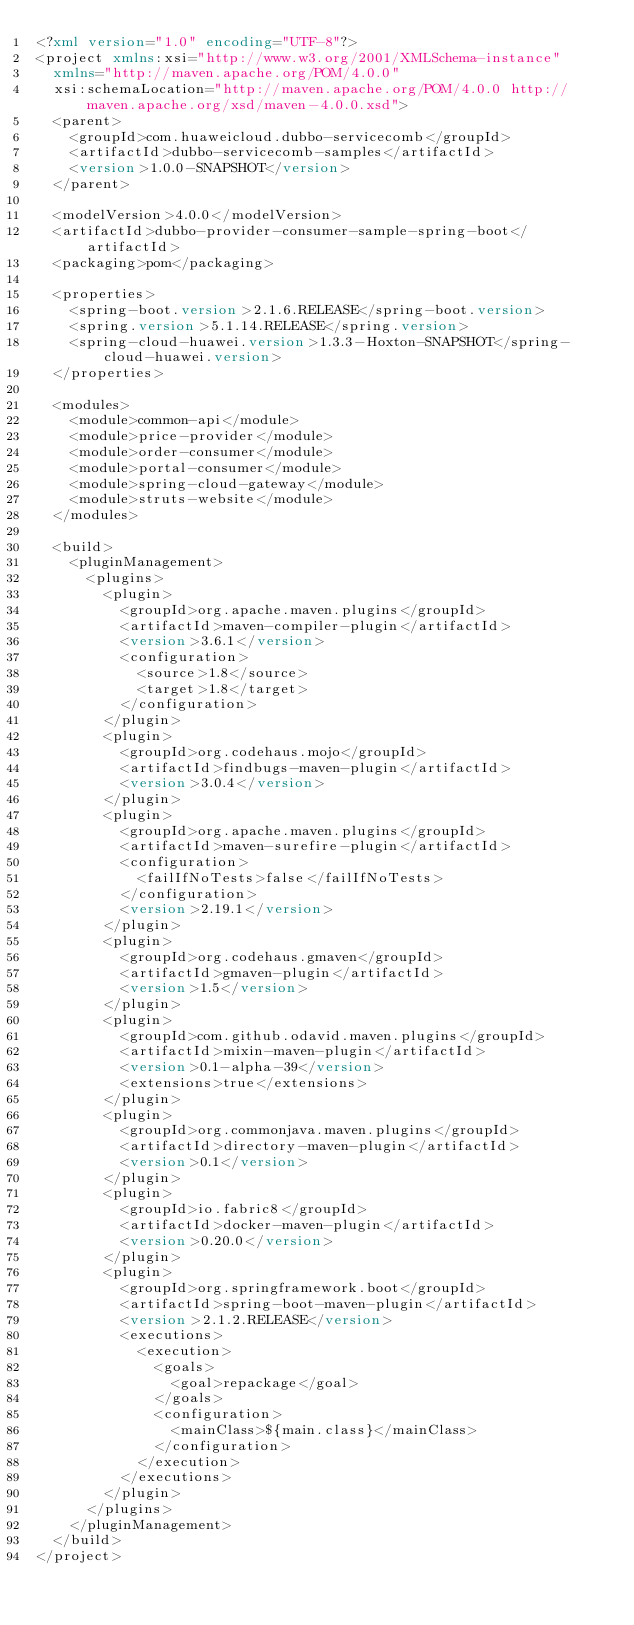<code> <loc_0><loc_0><loc_500><loc_500><_XML_><?xml version="1.0" encoding="UTF-8"?>
<project xmlns:xsi="http://www.w3.org/2001/XMLSchema-instance"
  xmlns="http://maven.apache.org/POM/4.0.0"
  xsi:schemaLocation="http://maven.apache.org/POM/4.0.0 http://maven.apache.org/xsd/maven-4.0.0.xsd">
  <parent>
    <groupId>com.huaweicloud.dubbo-servicecomb</groupId>
    <artifactId>dubbo-servicecomb-samples</artifactId>
    <version>1.0.0-SNAPSHOT</version>
  </parent>

  <modelVersion>4.0.0</modelVersion>
  <artifactId>dubbo-provider-consumer-sample-spring-boot</artifactId>
  <packaging>pom</packaging>

  <properties>
    <spring-boot.version>2.1.6.RELEASE</spring-boot.version>
    <spring.version>5.1.14.RELEASE</spring.version>
    <spring-cloud-huawei.version>1.3.3-Hoxton-SNAPSHOT</spring-cloud-huawei.version>
  </properties>

  <modules>
    <module>common-api</module>
    <module>price-provider</module>
    <module>order-consumer</module>
    <module>portal-consumer</module>
    <module>spring-cloud-gateway</module>
    <module>struts-website</module>
  </modules>

  <build>
    <pluginManagement>
      <plugins>
        <plugin>
          <groupId>org.apache.maven.plugins</groupId>
          <artifactId>maven-compiler-plugin</artifactId>
          <version>3.6.1</version>
          <configuration>
            <source>1.8</source>
            <target>1.8</target>
          </configuration>
        </plugin>
        <plugin>
          <groupId>org.codehaus.mojo</groupId>
          <artifactId>findbugs-maven-plugin</artifactId>
          <version>3.0.4</version>
        </plugin>
        <plugin>
          <groupId>org.apache.maven.plugins</groupId>
          <artifactId>maven-surefire-plugin</artifactId>
          <configuration>
            <failIfNoTests>false</failIfNoTests>
          </configuration>
          <version>2.19.1</version>
        </plugin>
        <plugin>
          <groupId>org.codehaus.gmaven</groupId>
          <artifactId>gmaven-plugin</artifactId>
          <version>1.5</version>
        </plugin>
        <plugin>
          <groupId>com.github.odavid.maven.plugins</groupId>
          <artifactId>mixin-maven-plugin</artifactId>
          <version>0.1-alpha-39</version>
          <extensions>true</extensions>
        </plugin>
        <plugin>
          <groupId>org.commonjava.maven.plugins</groupId>
          <artifactId>directory-maven-plugin</artifactId>
          <version>0.1</version>
        </plugin>
        <plugin>
          <groupId>io.fabric8</groupId>
          <artifactId>docker-maven-plugin</artifactId>
          <version>0.20.0</version>
        </plugin>
        <plugin>
          <groupId>org.springframework.boot</groupId>
          <artifactId>spring-boot-maven-plugin</artifactId>
          <version>2.1.2.RELEASE</version>
          <executions>
            <execution>
              <goals>
                <goal>repackage</goal>
              </goals>
              <configuration>
                <mainClass>${main.class}</mainClass>
              </configuration>
            </execution>
          </executions>
        </plugin>
      </plugins>
    </pluginManagement>
  </build>
</project></code> 